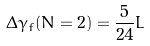<formula> <loc_0><loc_0><loc_500><loc_500>\Delta \gamma _ { f } ( N = 2 ) = \frac { 5 } { 2 4 } L</formula> 